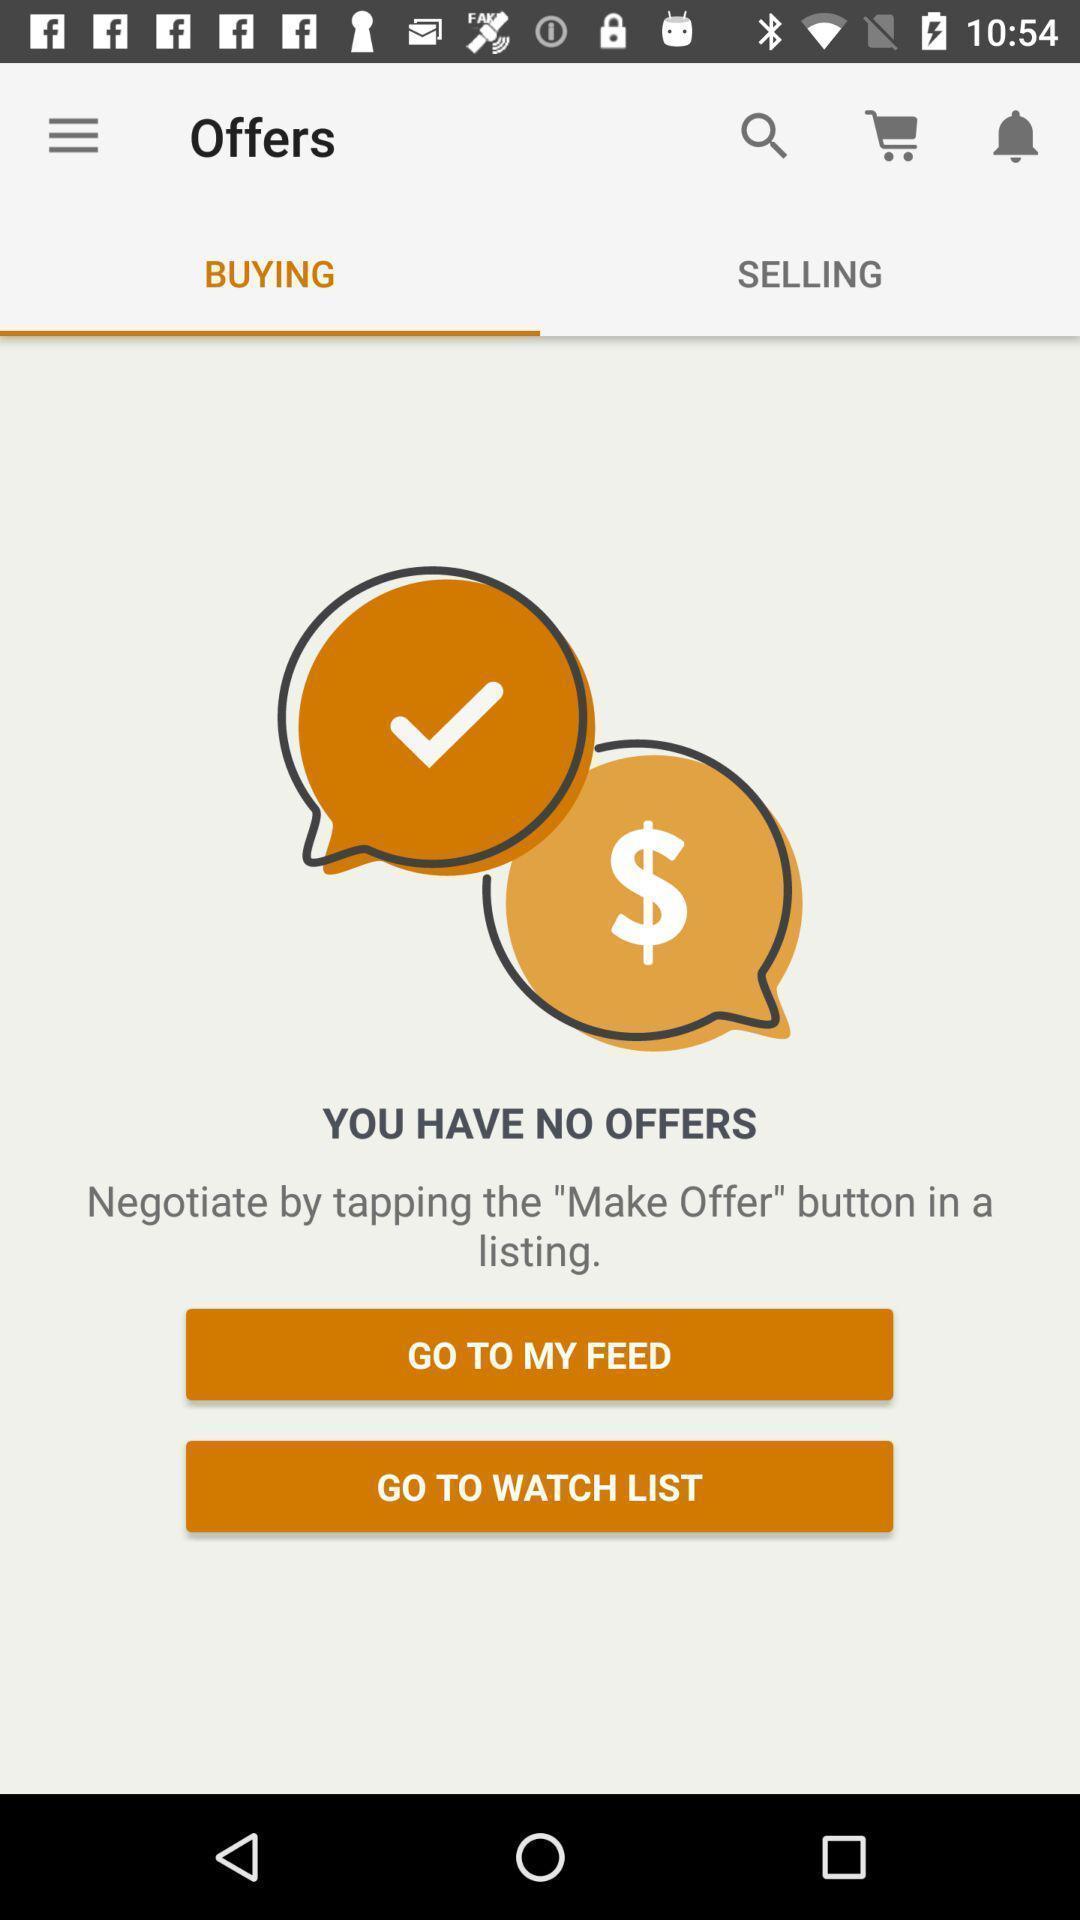Provide a description of this screenshot. Page displaying offers status. 